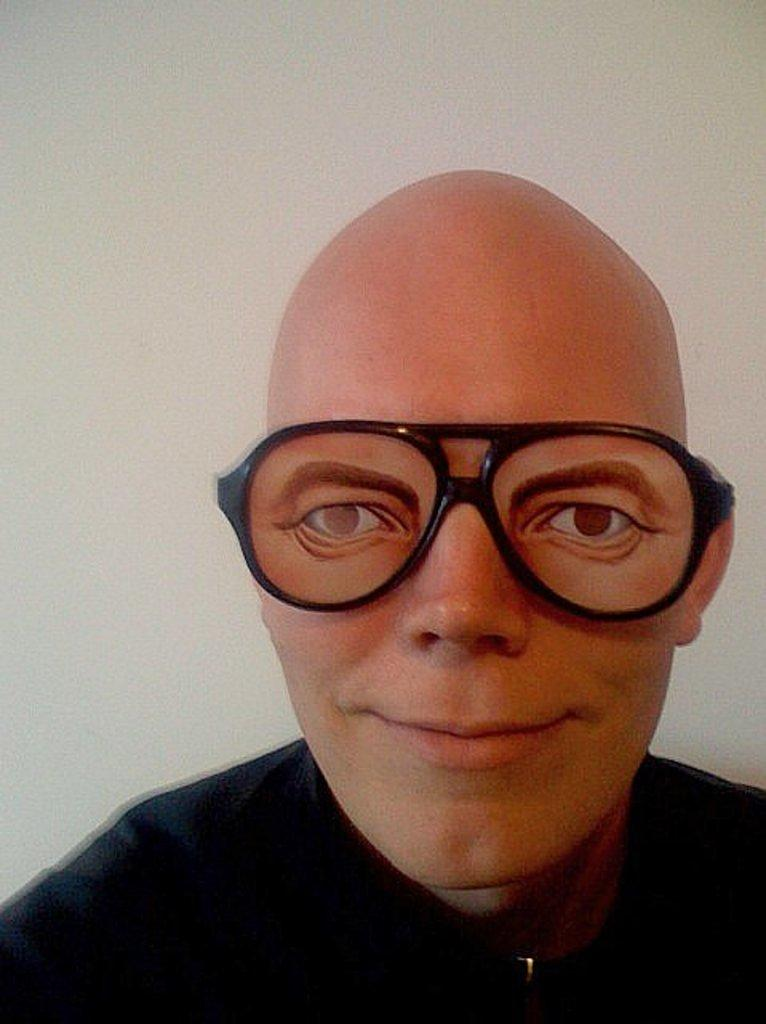What is the main subject of the image? There is a person in the image. What is the person wearing? The person is wearing a black dress and specs. What is the color of the background in the image? The background of the image is white. How many plants are visible in the image? There are no plants visible in the image; it features a person wearing a black dress and specs against a white background. Is there a girl in the image? The gender of the person in the image is not specified, so we cannot definitively say if it is a girl or not. 